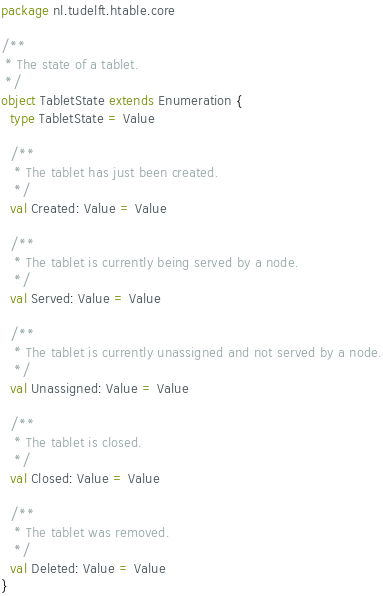<code> <loc_0><loc_0><loc_500><loc_500><_Scala_>package nl.tudelft.htable.core

/**
 * The state of a tablet.
 */
object TabletState extends Enumeration {
  type TabletState = Value

  /**
   * The tablet has just been created.
   */
  val Created: Value = Value

  /**
   * The tablet is currently being served by a node.
   */
  val Served: Value = Value

  /**
   * The tablet is currently unassigned and not served by a node.
   */
  val Unassigned: Value = Value

  /**
   * The tablet is closed.
   */
  val Closed: Value = Value

  /**
   * The tablet was removed.
   */
  val Deleted: Value = Value
}
</code> 